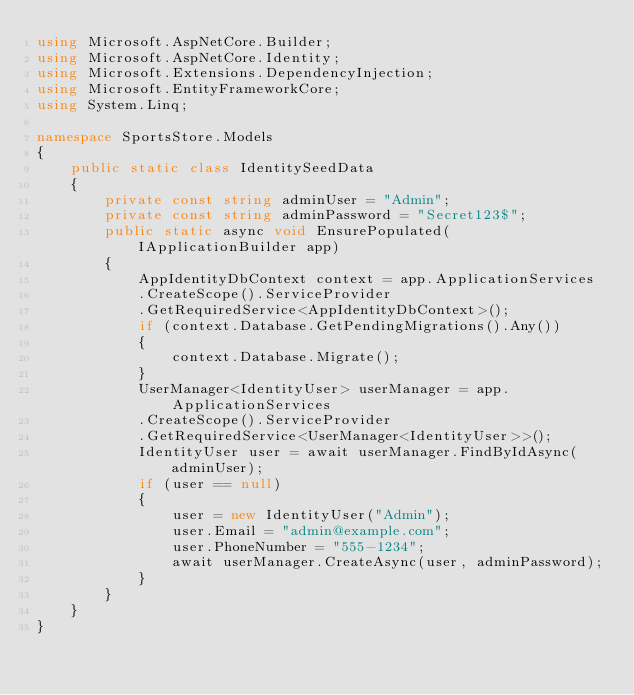<code> <loc_0><loc_0><loc_500><loc_500><_C#_>using Microsoft.AspNetCore.Builder;
using Microsoft.AspNetCore.Identity;
using Microsoft.Extensions.DependencyInjection;
using Microsoft.EntityFrameworkCore;
using System.Linq;

namespace SportsStore.Models
{
    public static class IdentitySeedData
    {
        private const string adminUser = "Admin";
        private const string adminPassword = "Secret123$";
        public static async void EnsurePopulated(IApplicationBuilder app)
        {
            AppIdentityDbContext context = app.ApplicationServices
            .CreateScope().ServiceProvider
            .GetRequiredService<AppIdentityDbContext>();
            if (context.Database.GetPendingMigrations().Any())
            {
                context.Database.Migrate();
            }
            UserManager<IdentityUser> userManager = app.ApplicationServices
            .CreateScope().ServiceProvider
            .GetRequiredService<UserManager<IdentityUser>>();
            IdentityUser user = await userManager.FindByIdAsync(adminUser);
            if (user == null)
            {
                user = new IdentityUser("Admin");
                user.Email = "admin@example.com";
                user.PhoneNumber = "555-1234";
                await userManager.CreateAsync(user, adminPassword);
            }
        }
    }
}</code> 